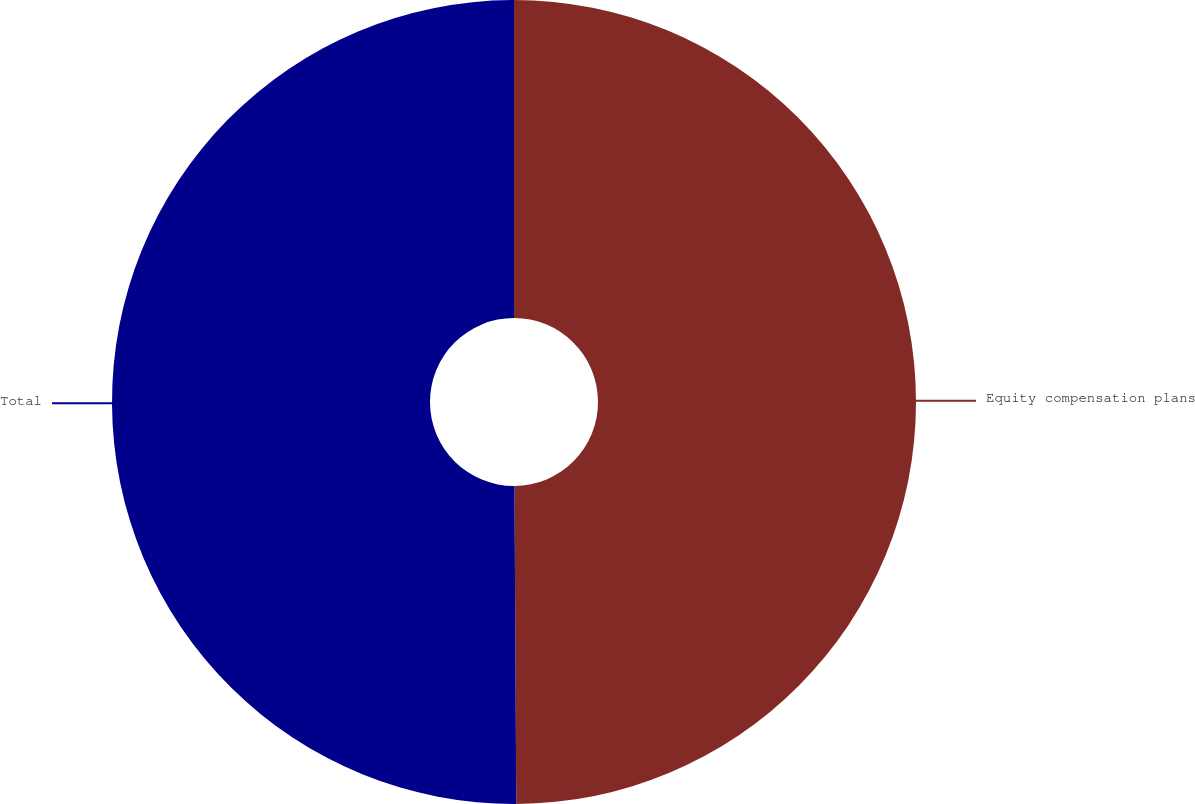Convert chart to OTSL. <chart><loc_0><loc_0><loc_500><loc_500><pie_chart><fcel>Equity compensation plans<fcel>Total<nl><fcel>49.91%<fcel>50.09%<nl></chart> 